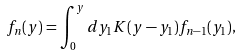<formula> <loc_0><loc_0><loc_500><loc_500>f _ { n } ( y ) = \int _ { 0 } ^ { y } d y _ { 1 } K ( y - y _ { 1 } ) f _ { n - 1 } ( y _ { 1 } ) ,</formula> 